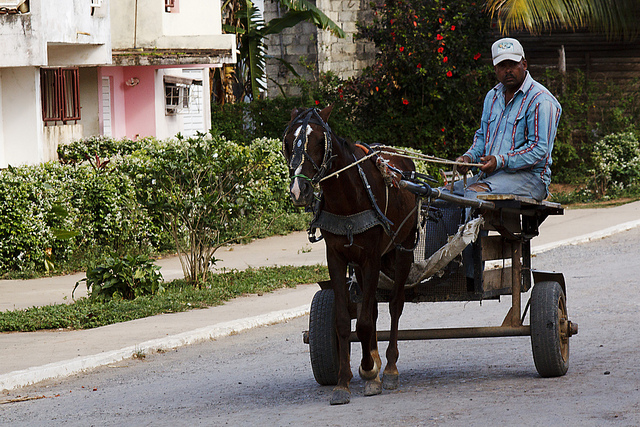<image>What type of shrub is on the sidewalk? I don't know the exact type of shrub on the sidewalk. It could be azalea, lilac, bush, fern or honeysuckle. What type of shrub is on the sidewalk? I don't know what type of shrub is on the sidewalk. It can be azalea, lilac, bushes, bush, fern, honeysuckle or something else. 